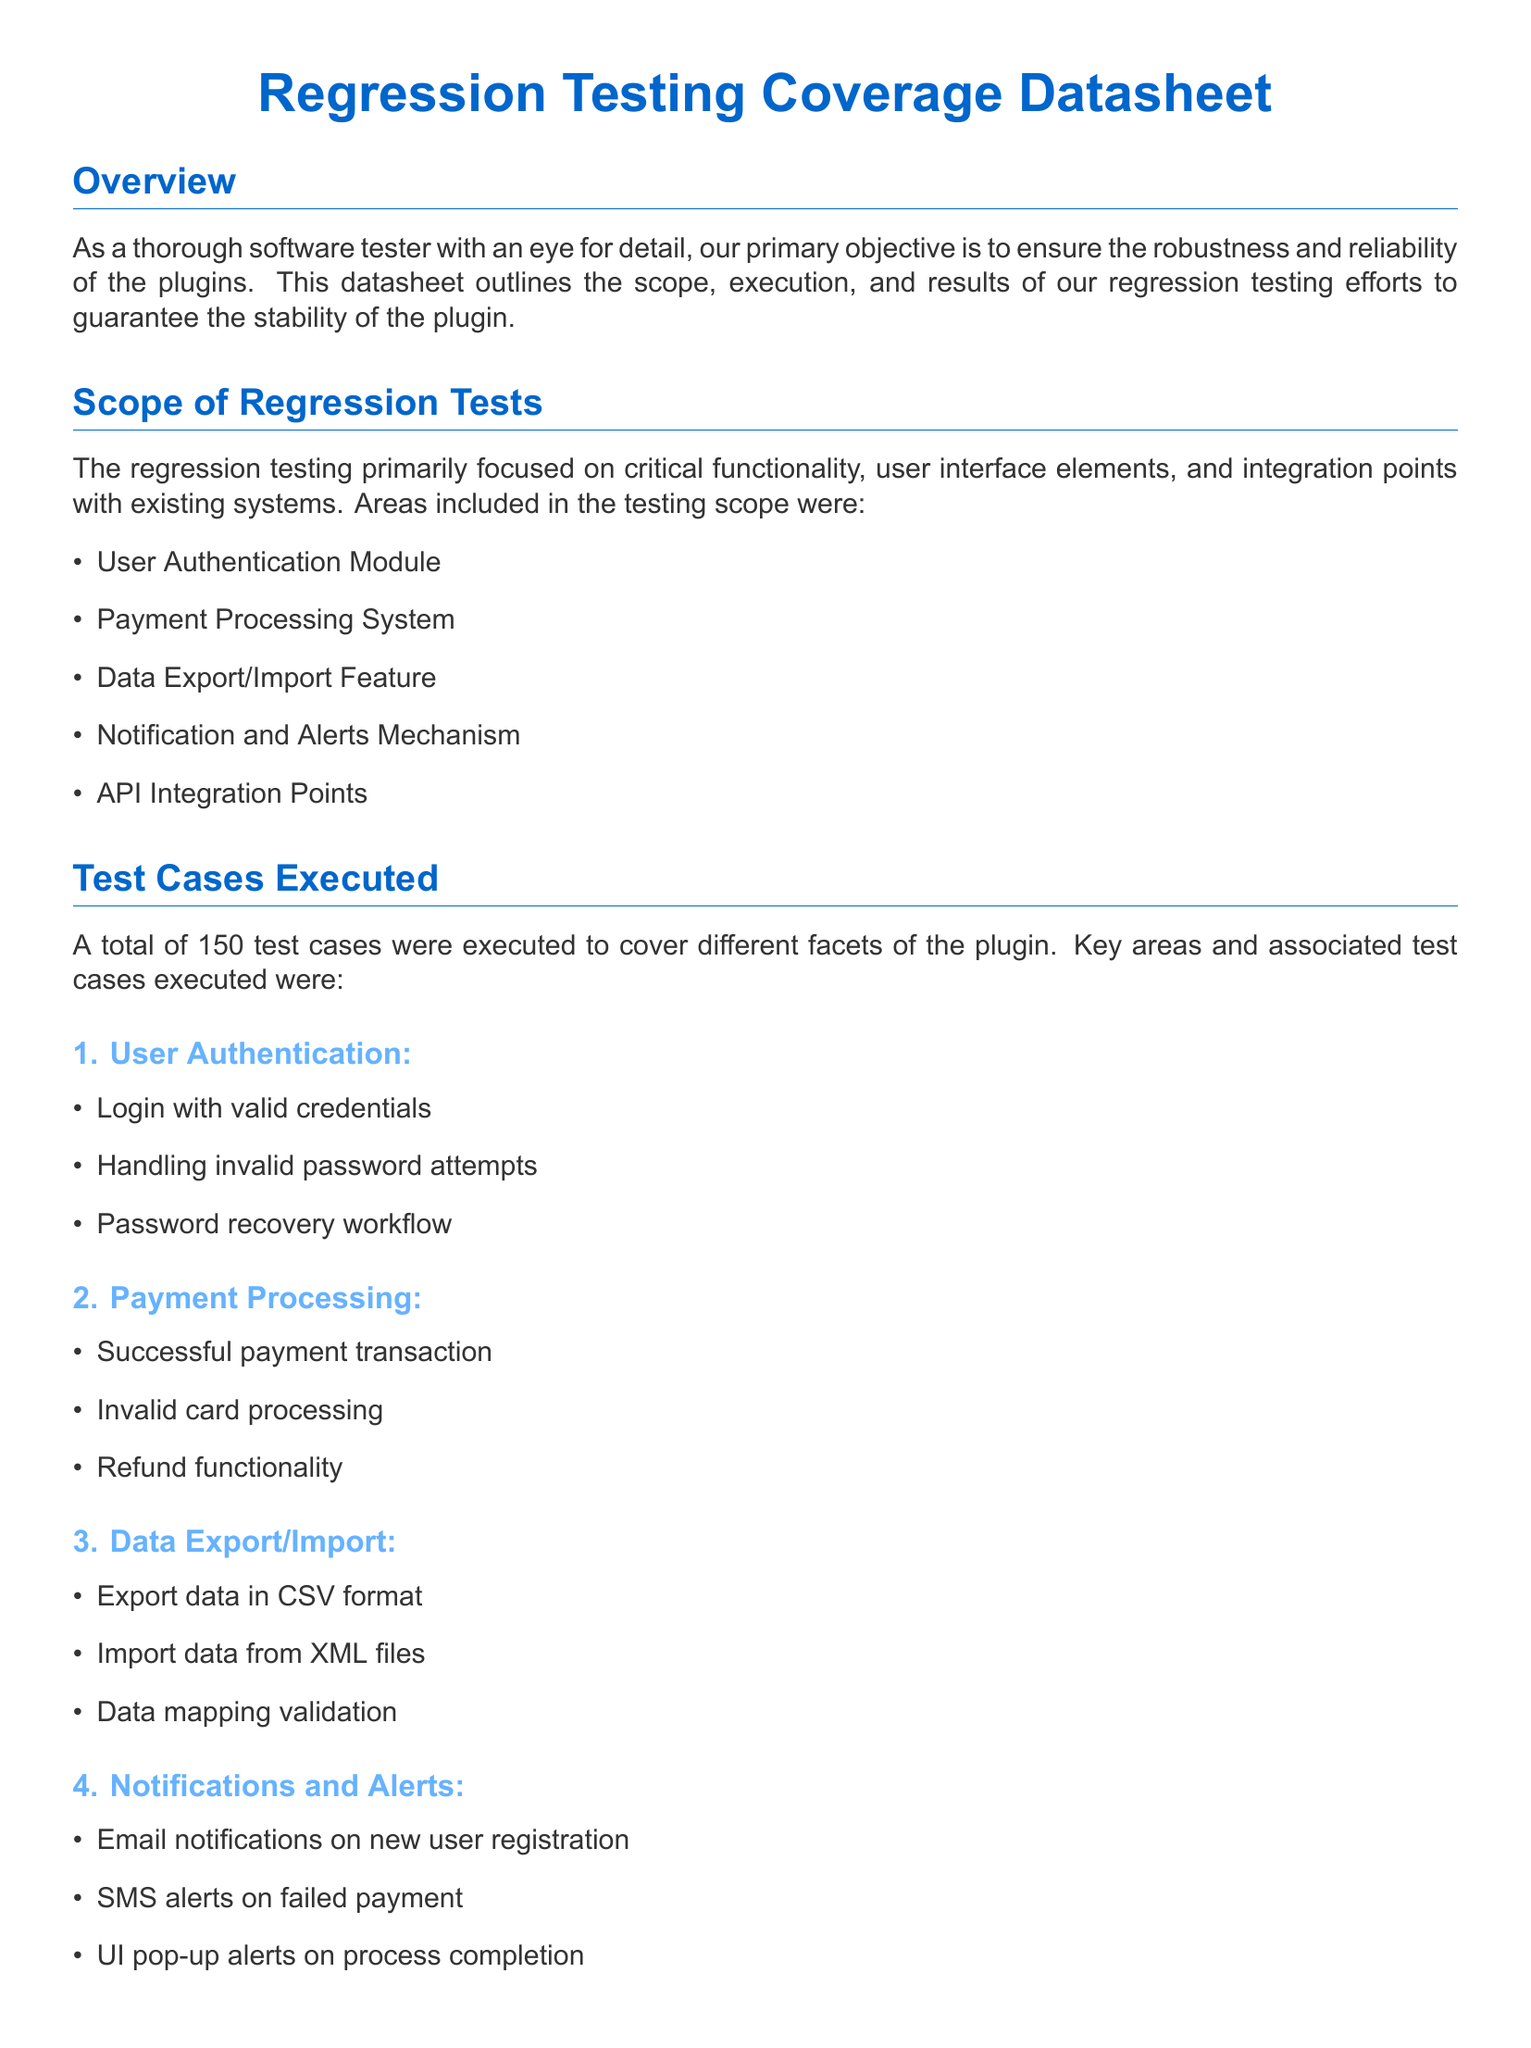What is the total number of test cases executed? The total number of test cases executed is explicitly stated in the document under the Final Results section.
Answer: 150 What percentage indicates the plugin's stability score? The stability score is provided in the Final Results section and represents the overall stability of the plugin.
Answer: 98% Which module experienced unexpected behavior during password recovery? The module with the bug during password recovery is mentioned in the Areas Where Bugs Were Found and Fixed section.
Answer: User Authentication How long did the regression testing take? The duration of the testing is mentioned in the Final Results section, reflecting the time span for all tests.
Answer: 2 weeks What area had bugs related to delays in notifications? The specific area where the bug occurred is detailed in the Areas Where Bugs Were Found section, indicating where the fixes were made.
Answer: Notifications and Alerts How many bugs were found and subsequently fixed? The total count of found and fixed bugs is listed in the Final Results section, summarizing testing outcomes.
Answer: 12 What is included in the scope of regression tests? The scope lists specific features tested and is highlighted in the Scope of Regression Tests section.
Answer: User Authentication Module, Payment Processing System, Data Export/Import Feature, Notification and Alerts Mechanism, API Integration Points What types of cases were executed under API integration? The types of test cases are specified in the Test Cases Executed section regarding API Integration.
Answer: Data retrieval from external APIs, Handling API response errors, Performance testing of API calls What was corrected in the email validation logic? The specific fix made is noted under Areas Where Bugs Were Found and Fixed, presenting the resolution to a bug.
Answer: Corrected the email validation logic 